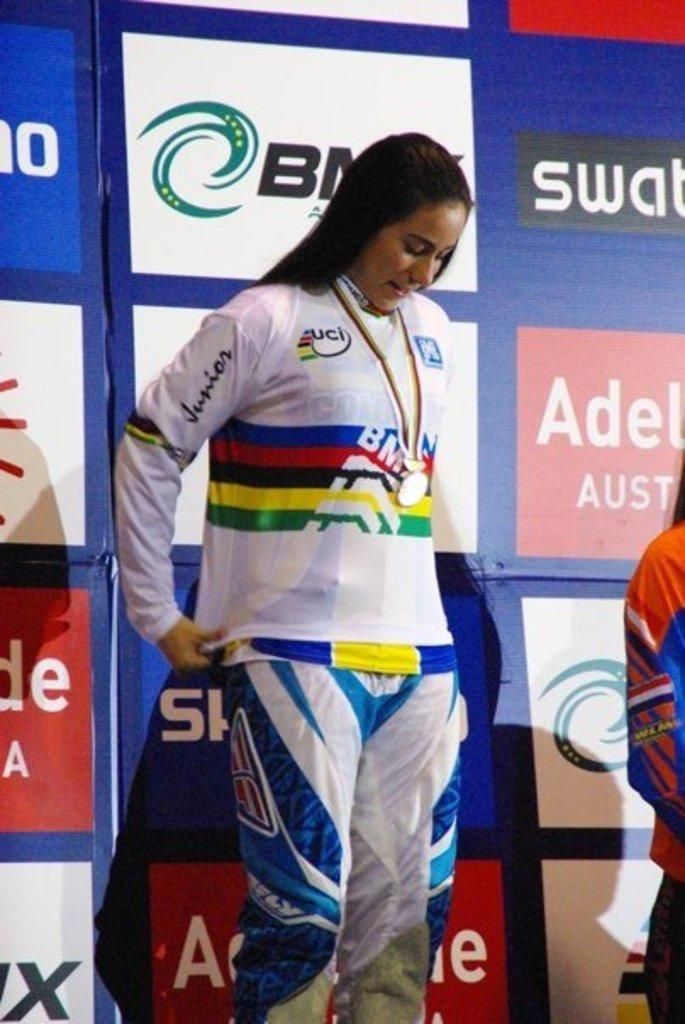<image>
Present a compact description of the photo's key features. Woman in sports wear standing behind advertising board with Aus to her right 